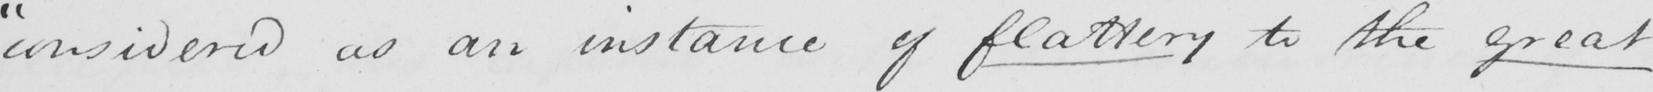Please provide the text content of this handwritten line. " considered as an instance of flattery to the great 